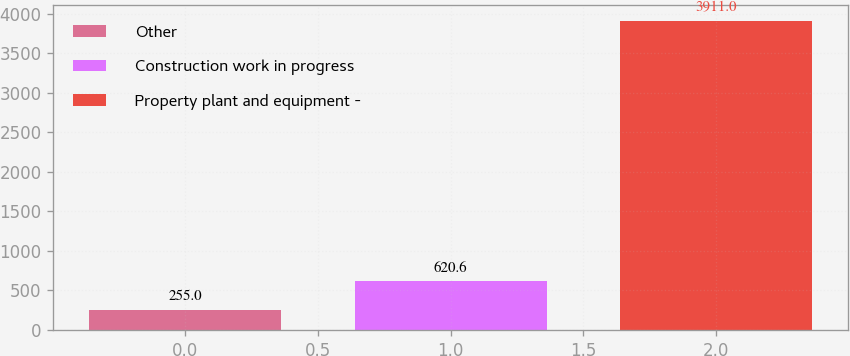Convert chart to OTSL. <chart><loc_0><loc_0><loc_500><loc_500><bar_chart><fcel>Other<fcel>Construction work in progress<fcel>Property plant and equipment -<nl><fcel>255<fcel>620.6<fcel>3911<nl></chart> 